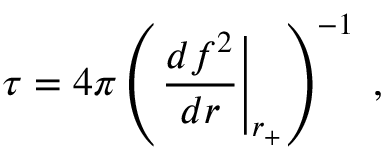<formula> <loc_0><loc_0><loc_500><loc_500>\tau = 4 \pi \left ( \frac { d f ^ { 2 } } { d r } \right | _ { r _ { + } } \right ) ^ { - 1 } \, ,</formula> 